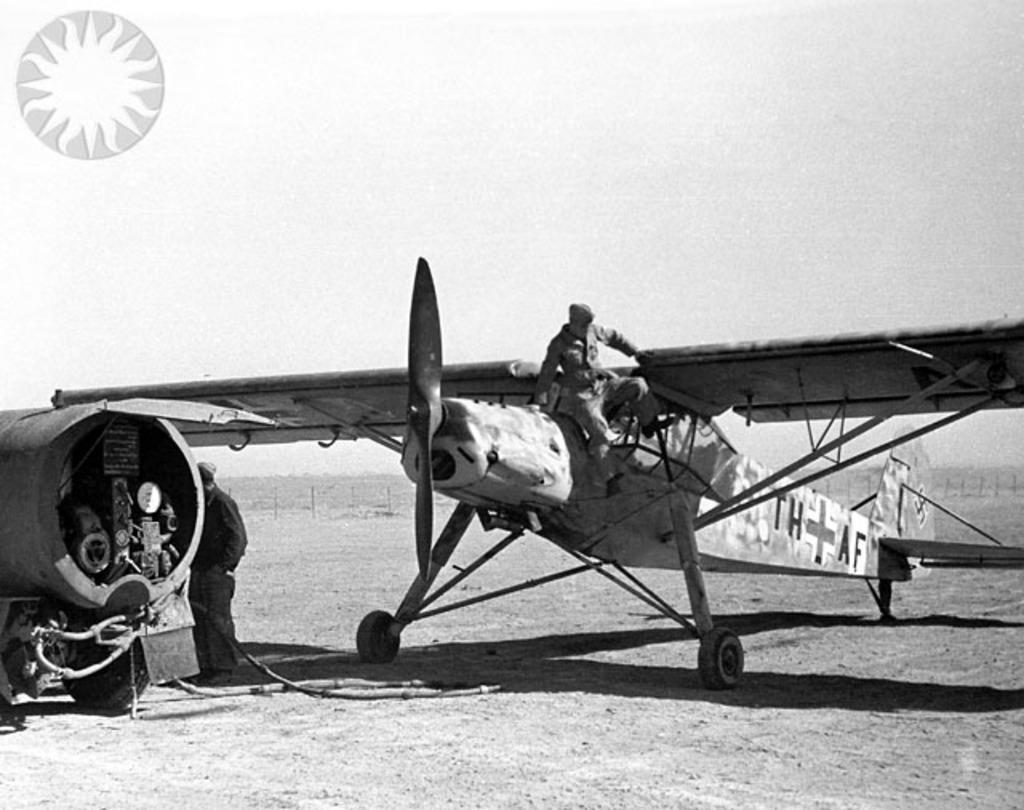How would you summarize this image in a sentence or two? This image is a black and white image. This image is taken outdoors. At the bottom of the image there is a ground. In the middle of the image there is an airplane on the ground. A man is climbing on the airplane. On the left side of the image there is a vehicle on the ground and a man is standing on the ground. 